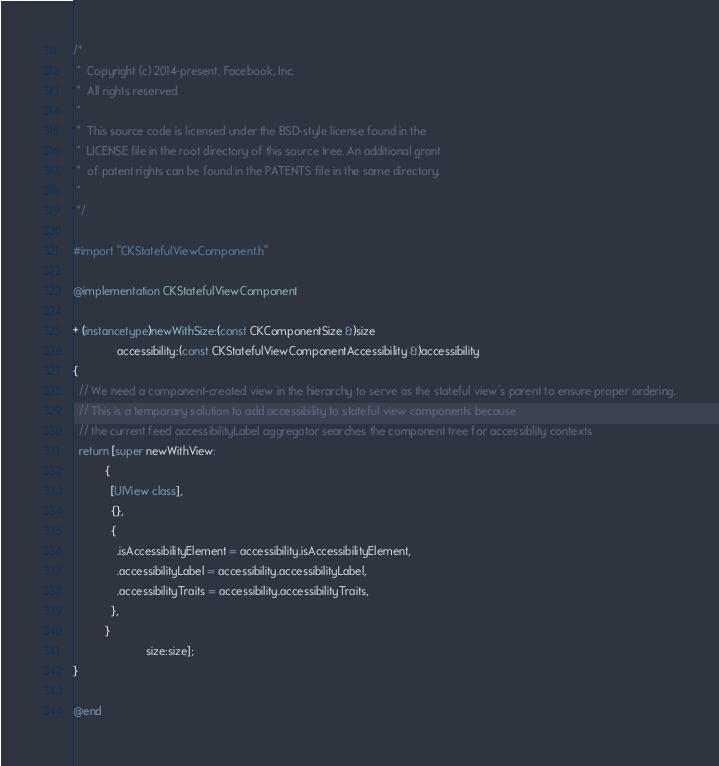Convert code to text. <code><loc_0><loc_0><loc_500><loc_500><_ObjectiveC_>/*
 *  Copyright (c) 2014-present, Facebook, Inc.
 *  All rights reserved.
 *
 *  This source code is licensed under the BSD-style license found in the
 *  LICENSE file in the root directory of this source tree. An additional grant
 *  of patent rights can be found in the PATENTS file in the same directory.
 *
 */

#import "CKStatefulViewComponent.h"

@implementation CKStatefulViewComponent

+ (instancetype)newWithSize:(const CKComponentSize &)size
              accessibility:(const CKStatefulViewComponentAccessibility &)accessibility
{
  // We need a component-created view in the hierarchy to serve as the stateful view's parent to ensure proper ordering.
  // This is a temporary solution to add accessibility to stateful view components because
  // the current feed accessibilityLabel aggregator searches the component tree for accessiblity contexts
  return [super newWithView:
          {
            [UIView class],
            {},
            {
              .isAccessibilityElement = accessibility.isAccessibilityElement,
              .accessibilityLabel = accessibility.accessibilityLabel,
              .accessibilityTraits = accessibility.accessibilityTraits,
            },
          }
                       size:size];
}

@end
</code> 